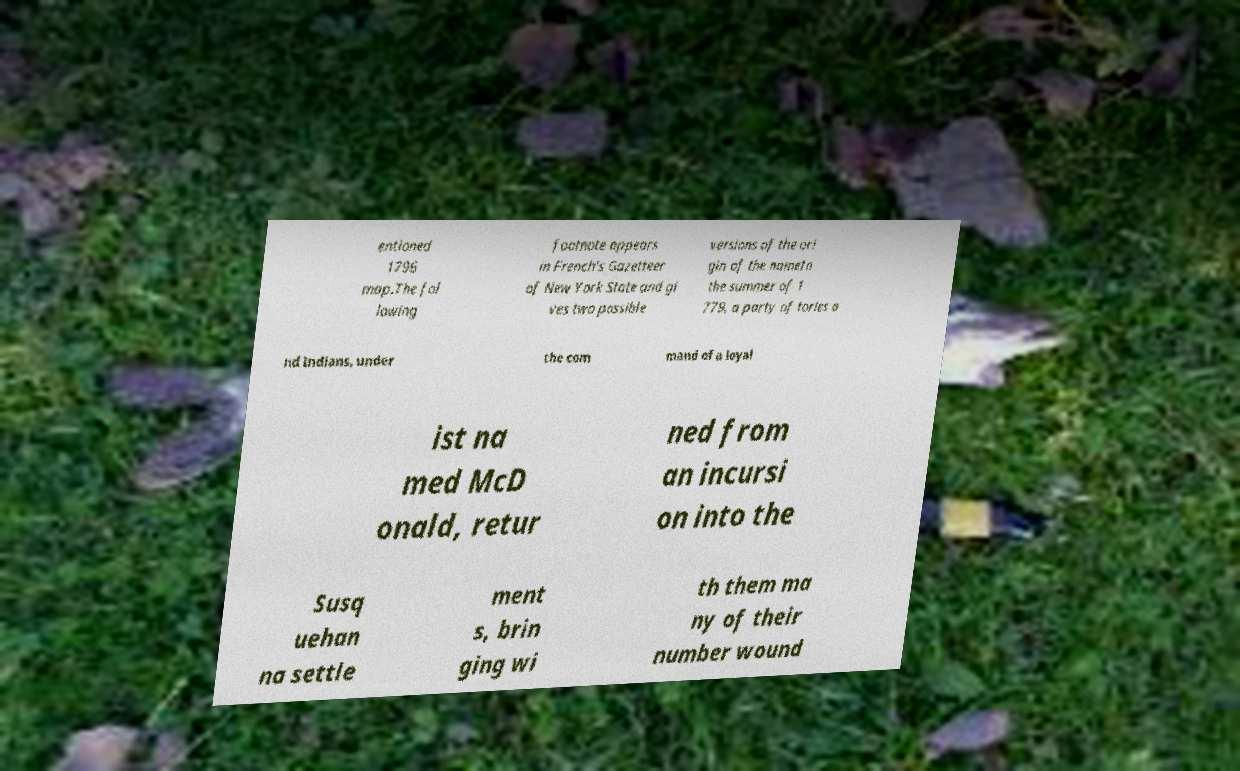Please read and relay the text visible in this image. What does it say? entioned 1796 map.The fol lowing footnote appears in French's Gazetteer of New York State and gi ves two possible versions of the ori gin of the nameIn the summer of 1 779, a party of tories a nd Indians, under the com mand of a loyal ist na med McD onald, retur ned from an incursi on into the Susq uehan na settle ment s, brin ging wi th them ma ny of their number wound 